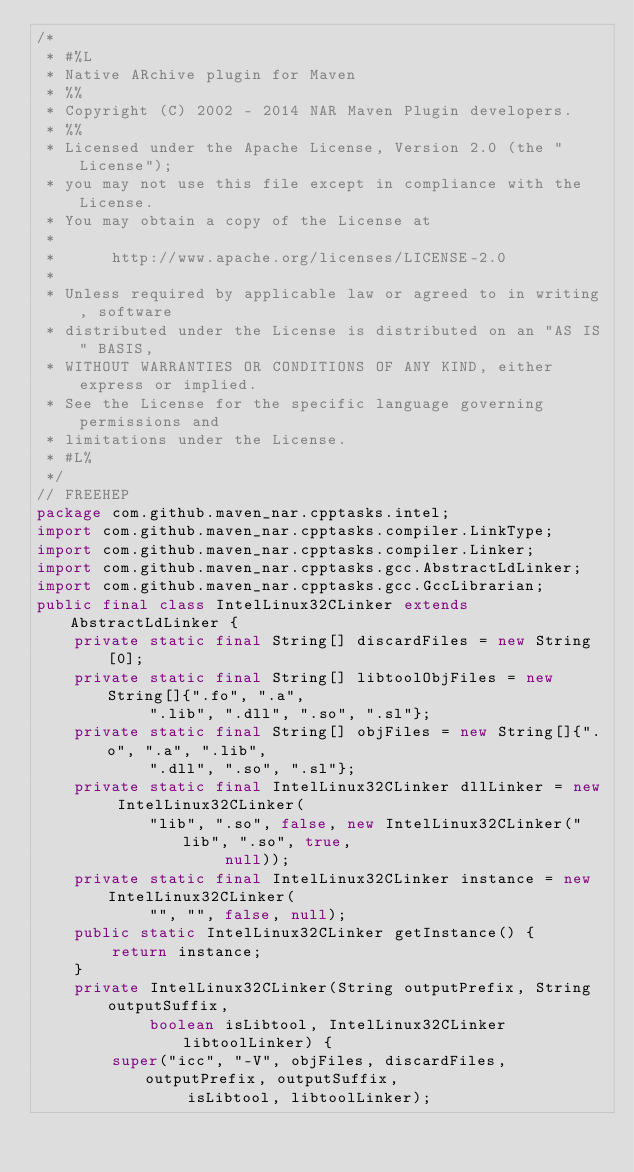<code> <loc_0><loc_0><loc_500><loc_500><_Java_>/*
 * #%L
 * Native ARchive plugin for Maven
 * %%
 * Copyright (C) 2002 - 2014 NAR Maven Plugin developers.
 * %%
 * Licensed under the Apache License, Version 2.0 (the "License");
 * you may not use this file except in compliance with the License.
 * You may obtain a copy of the License at
 * 
 *      http://www.apache.org/licenses/LICENSE-2.0
 * 
 * Unless required by applicable law or agreed to in writing, software
 * distributed under the License is distributed on an "AS IS" BASIS,
 * WITHOUT WARRANTIES OR CONDITIONS OF ANY KIND, either express or implied.
 * See the License for the specific language governing permissions and
 * limitations under the License.
 * #L%
 */
// FREEHEP
package com.github.maven_nar.cpptasks.intel;
import com.github.maven_nar.cpptasks.compiler.LinkType;
import com.github.maven_nar.cpptasks.compiler.Linker;
import com.github.maven_nar.cpptasks.gcc.AbstractLdLinker;
import com.github.maven_nar.cpptasks.gcc.GccLibrarian;
public final class IntelLinux32CLinker extends AbstractLdLinker {
    private static final String[] discardFiles = new String[0];
    private static final String[] libtoolObjFiles = new String[]{".fo", ".a",
            ".lib", ".dll", ".so", ".sl"};
    private static final String[] objFiles = new String[]{".o", ".a", ".lib",
            ".dll", ".so", ".sl"};
    private static final IntelLinux32CLinker dllLinker = new IntelLinux32CLinker(
            "lib", ".so", false, new IntelLinux32CLinker("lib", ".so", true,
                    null));
    private static final IntelLinux32CLinker instance = new IntelLinux32CLinker(
            "", "", false, null);
    public static IntelLinux32CLinker getInstance() {
        return instance;
    }
    private IntelLinux32CLinker(String outputPrefix, String outputSuffix,
            boolean isLibtool, IntelLinux32CLinker libtoolLinker) {
        super("icc", "-V", objFiles, discardFiles, outputPrefix, outputSuffix,
                isLibtool, libtoolLinker);</code> 